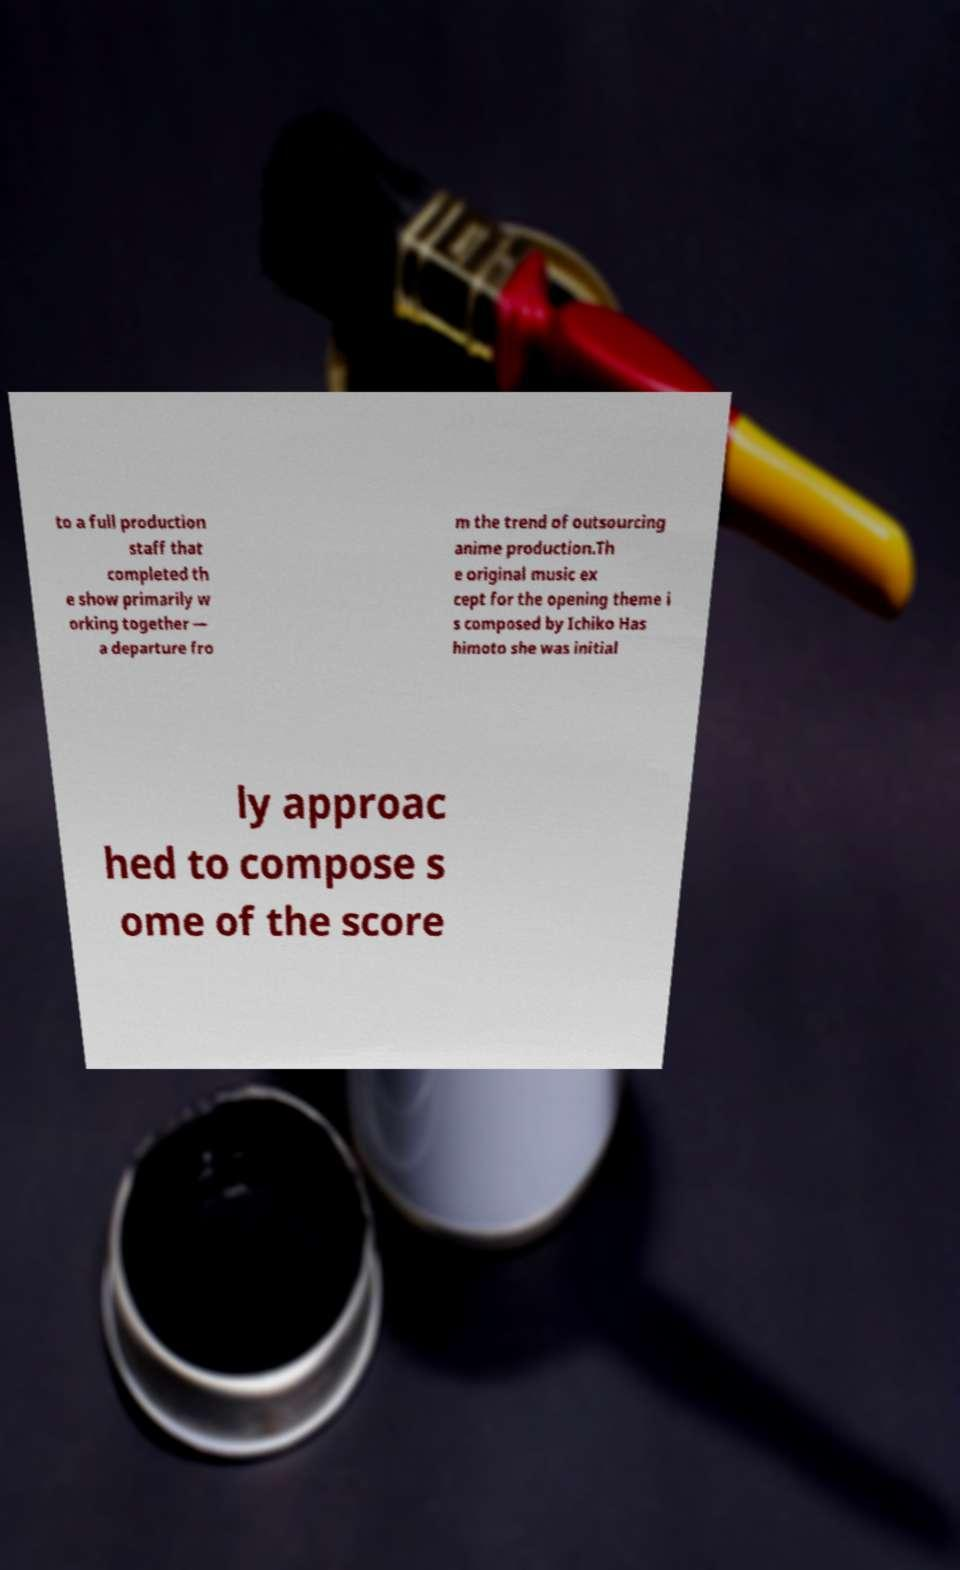There's text embedded in this image that I need extracted. Can you transcribe it verbatim? to a full production staff that completed th e show primarily w orking together — a departure fro m the trend of outsourcing anime production.Th e original music ex cept for the opening theme i s composed by Ichiko Has himoto she was initial ly approac hed to compose s ome of the score 